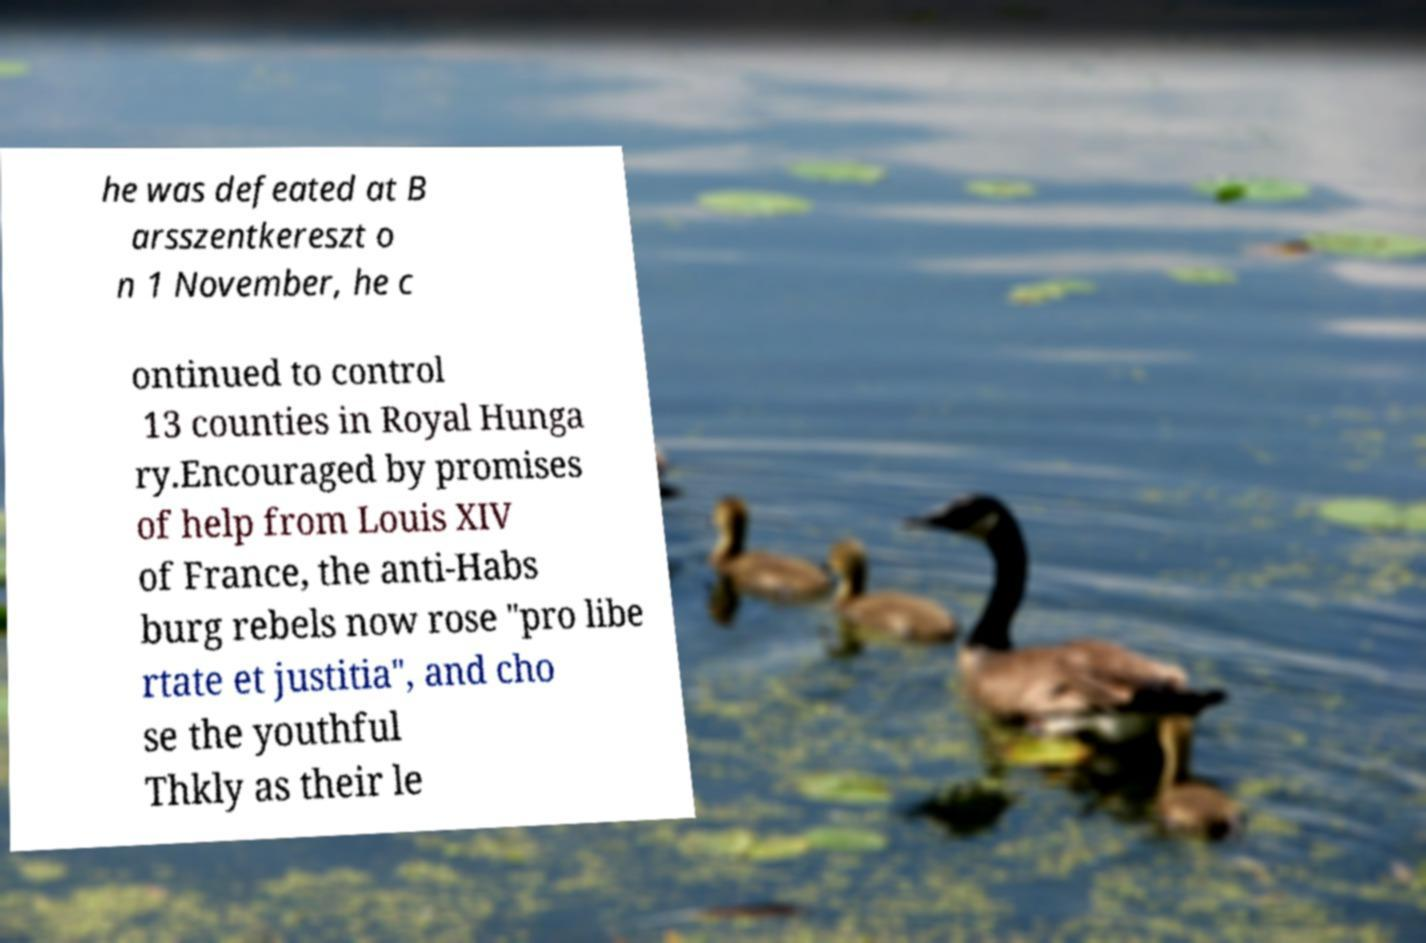Could you extract and type out the text from this image? he was defeated at B arsszentkereszt o n 1 November, he c ontinued to control 13 counties in Royal Hunga ry.Encouraged by promises of help from Louis XIV of France, the anti-Habs burg rebels now rose "pro libe rtate et justitia", and cho se the youthful Thkly as their le 